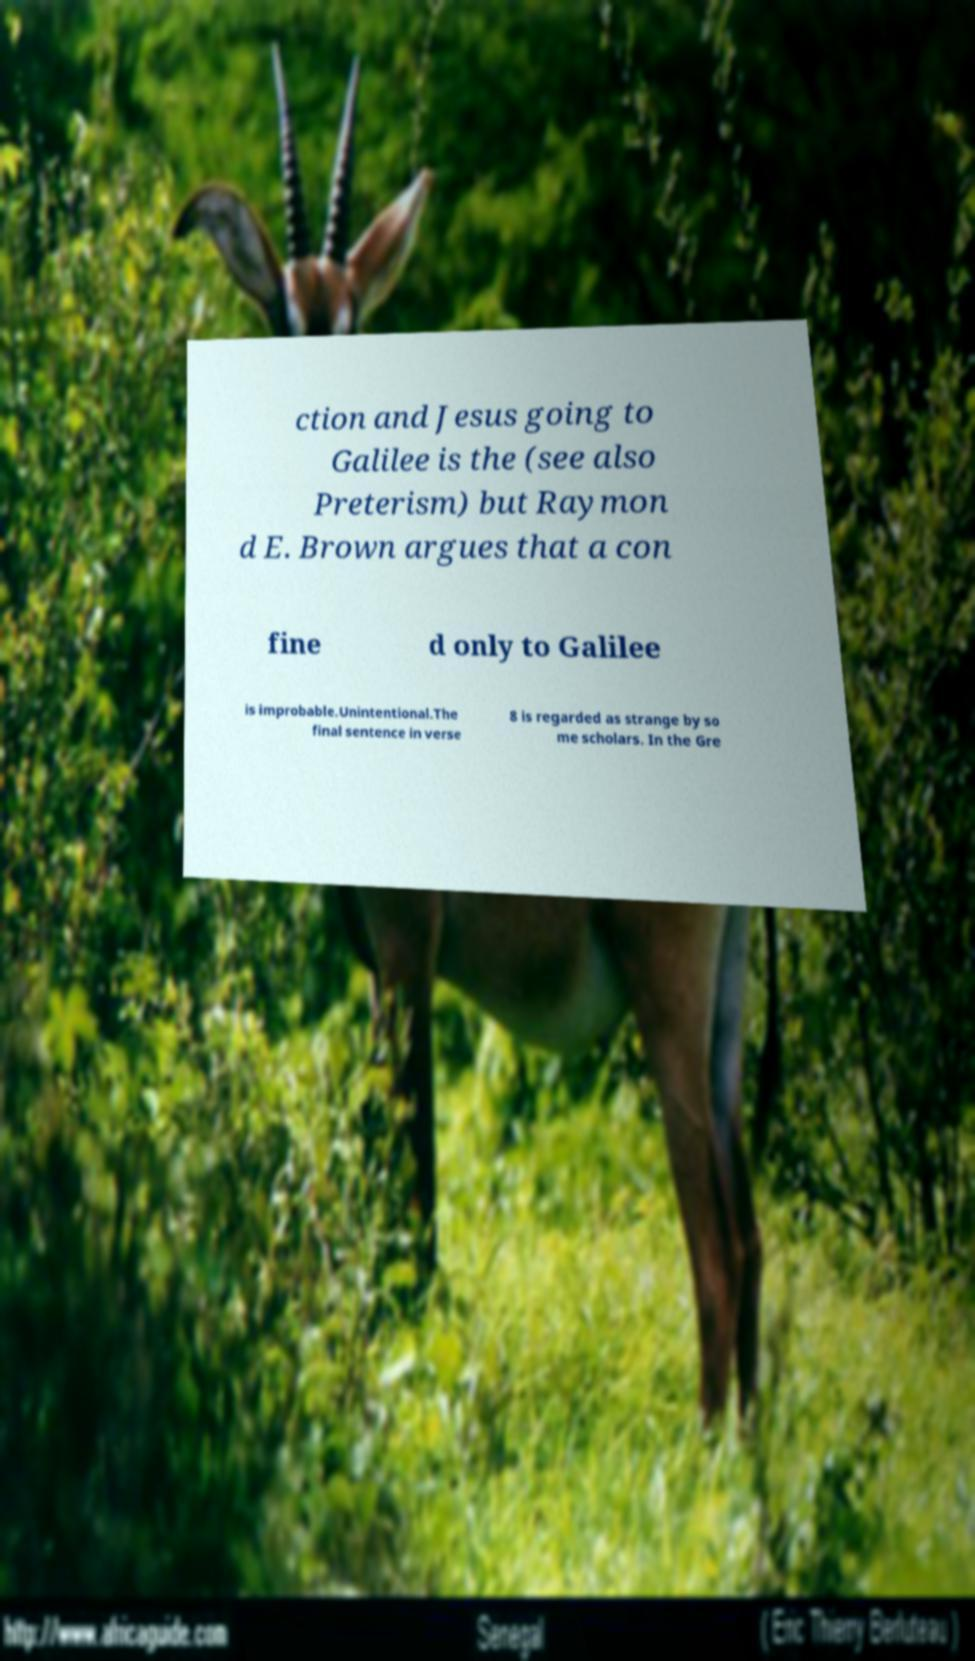Please read and relay the text visible in this image. What does it say? ction and Jesus going to Galilee is the (see also Preterism) but Raymon d E. Brown argues that a con fine d only to Galilee is improbable.Unintentional.The final sentence in verse 8 is regarded as strange by so me scholars. In the Gre 